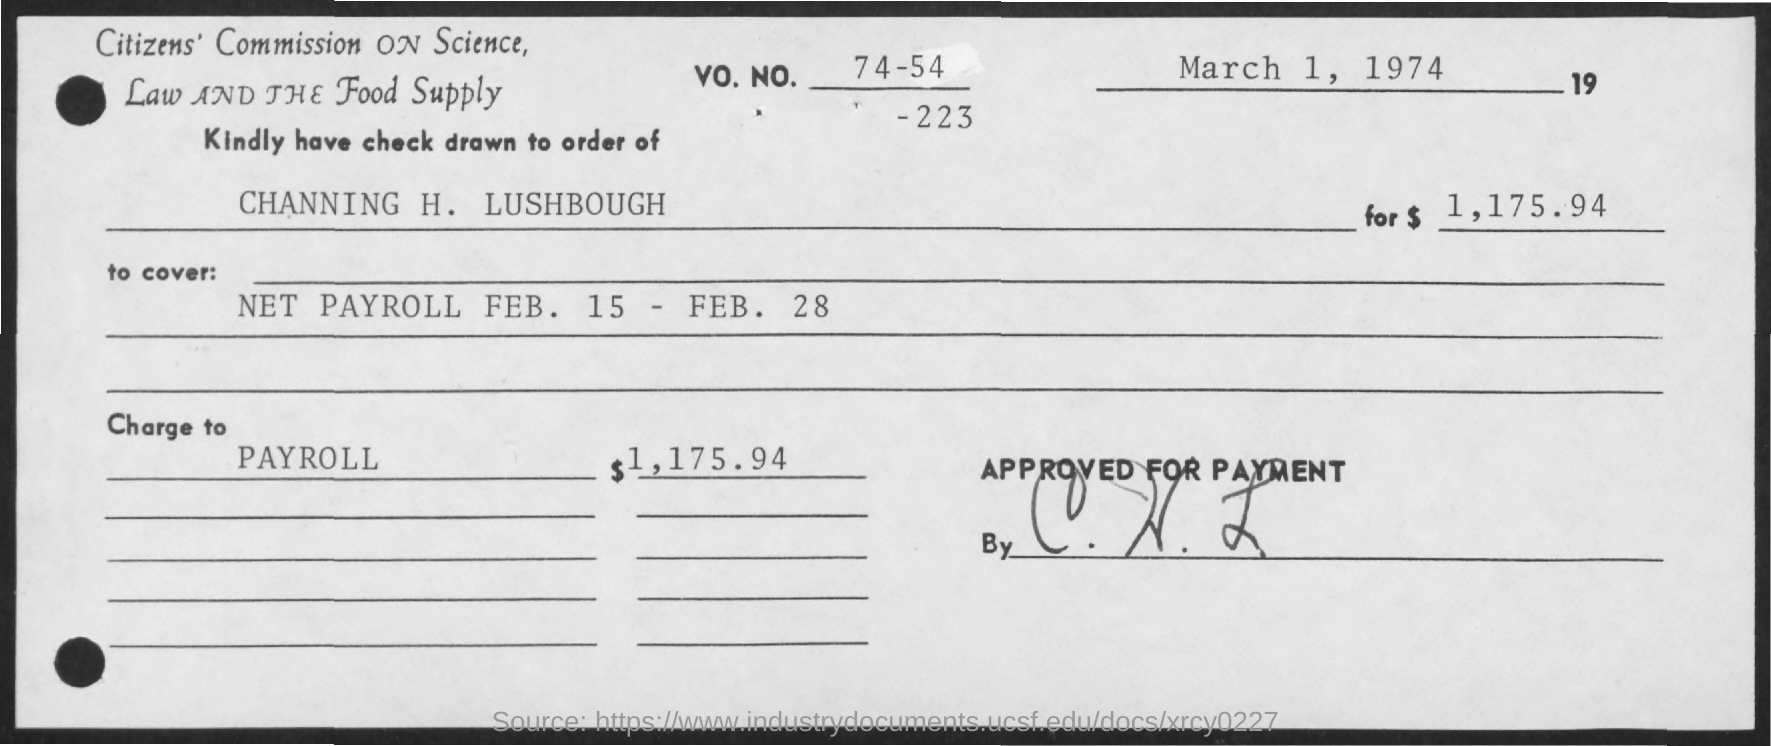The check is drawn to the order of?
Offer a very short reply. Channing H. Lushbough. What is the Date?
Your answer should be compact. March 1, 1974. What is the VO. NO.?
Provide a short and direct response. 74-54-223. What is the Amount?
Provide a succinct answer. $1,175.94. What is the "charge to" for Payroll?
Your answer should be very brief. $1,175.94. 